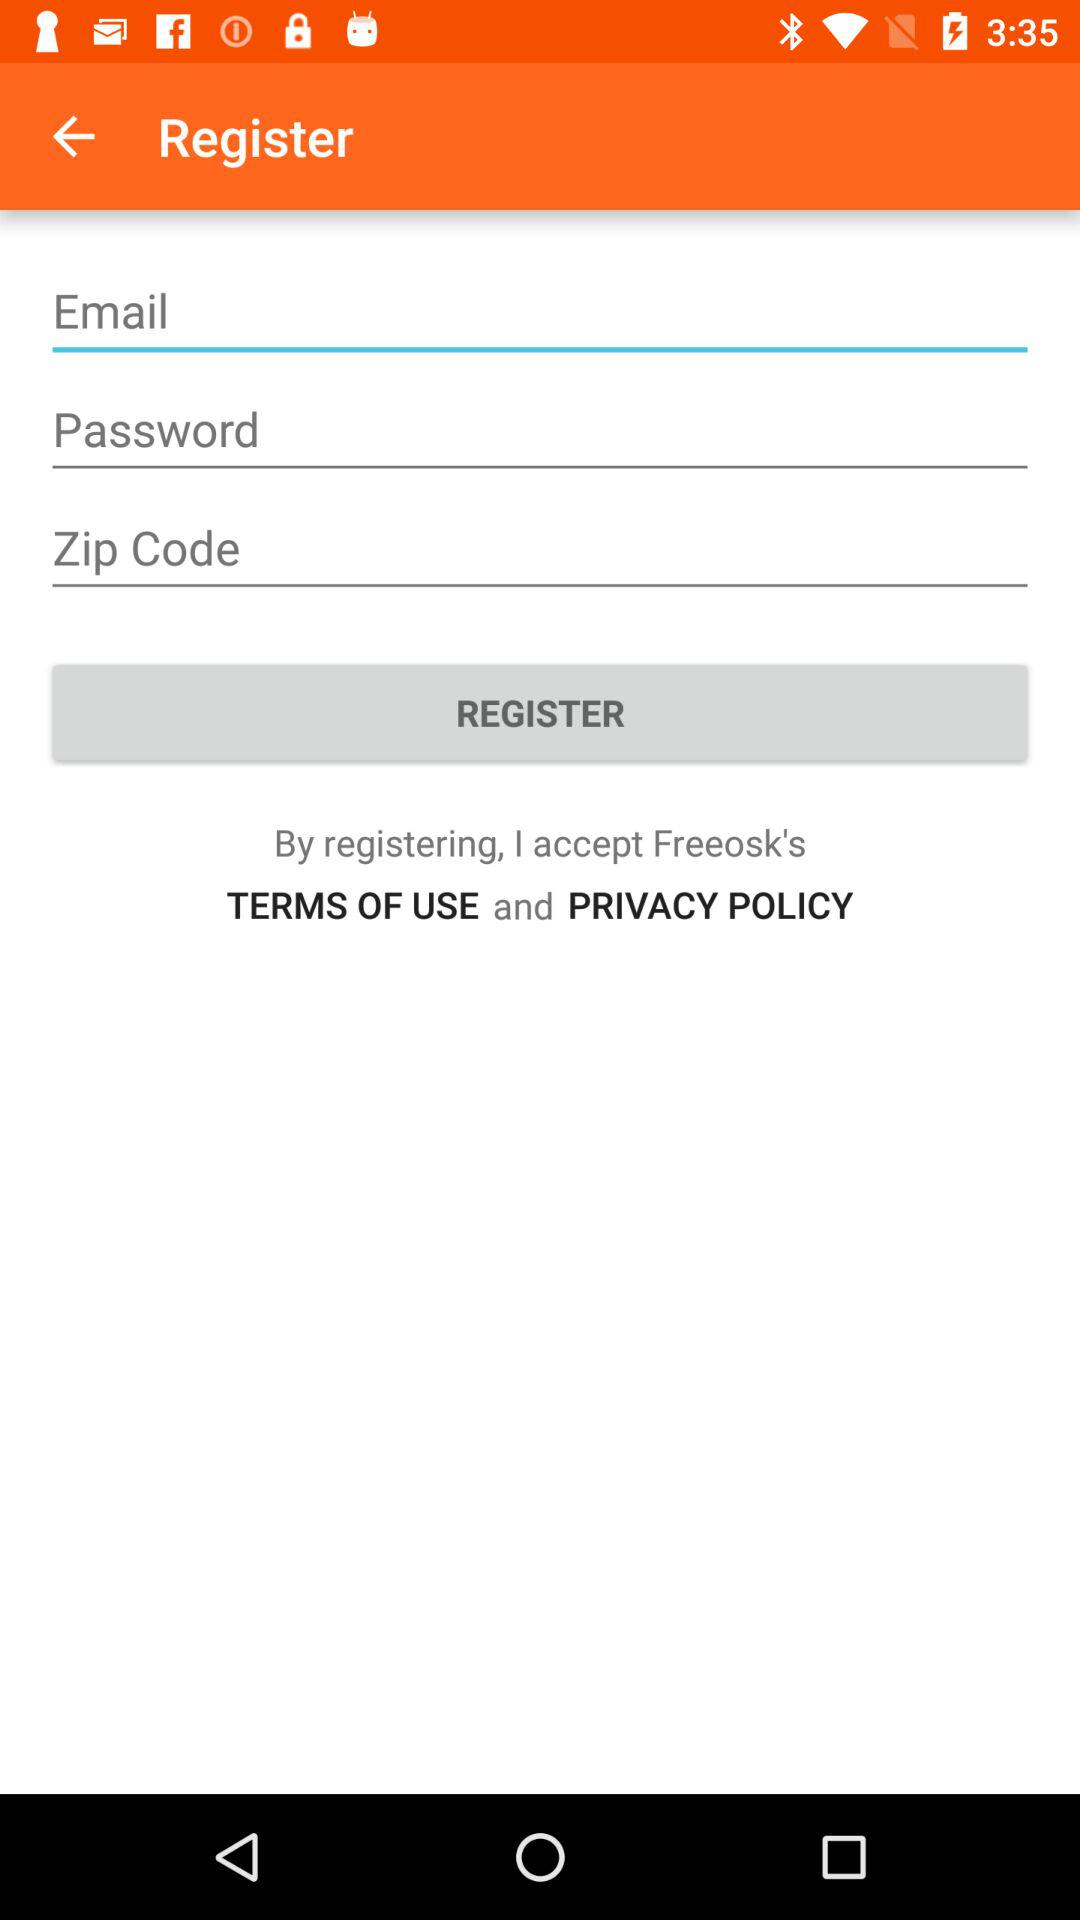How many text fields are there on the screen?
Answer the question using a single word or phrase. 3 